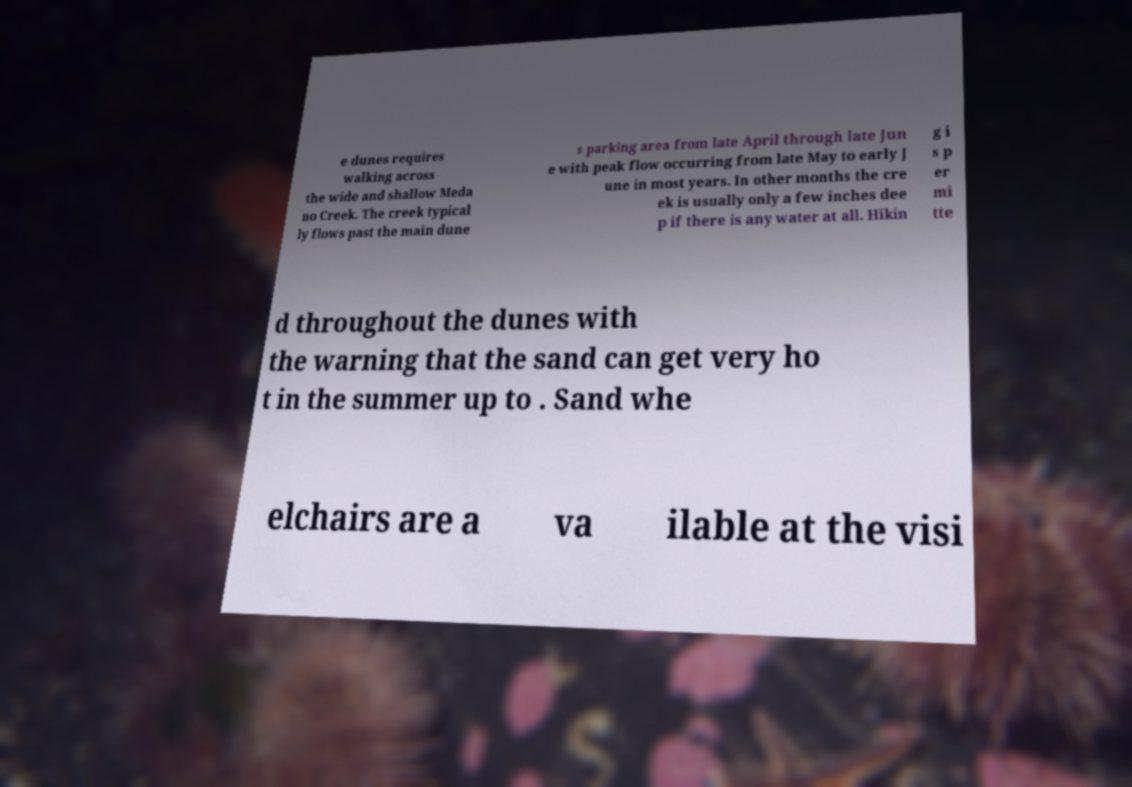For documentation purposes, I need the text within this image transcribed. Could you provide that? e dunes requires walking across the wide and shallow Meda no Creek. The creek typical ly flows past the main dune s parking area from late April through late Jun e with peak flow occurring from late May to early J une in most years. In other months the cre ek is usually only a few inches dee p if there is any water at all. Hikin g i s p er mi tte d throughout the dunes with the warning that the sand can get very ho t in the summer up to . Sand whe elchairs are a va ilable at the visi 